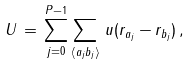Convert formula to latex. <formula><loc_0><loc_0><loc_500><loc_500>U \, = \, \sum _ { j = 0 } ^ { P - 1 } \sum _ { \langle a _ { j } b _ { j } \rangle } \, u ( { r } _ { a _ { j } } - { r } _ { b _ { j } } ) \, ,</formula> 